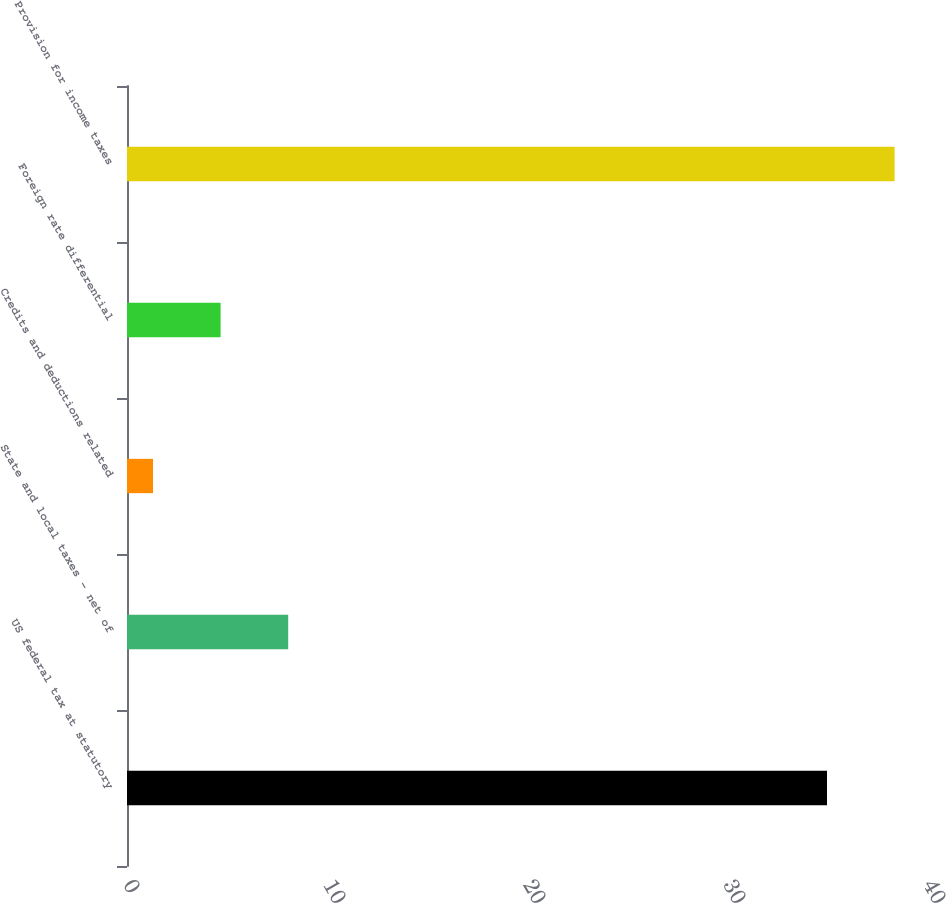Convert chart. <chart><loc_0><loc_0><loc_500><loc_500><bar_chart><fcel>US federal tax at statutory<fcel>State and local taxes - net of<fcel>Credits and deductions related<fcel>Foreign rate differential<fcel>Provision for income taxes<nl><fcel>35<fcel>8.06<fcel>1.3<fcel>4.68<fcel>38.38<nl></chart> 